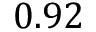Convert formula to latex. <formula><loc_0><loc_0><loc_500><loc_500>0 . 9 2</formula> 